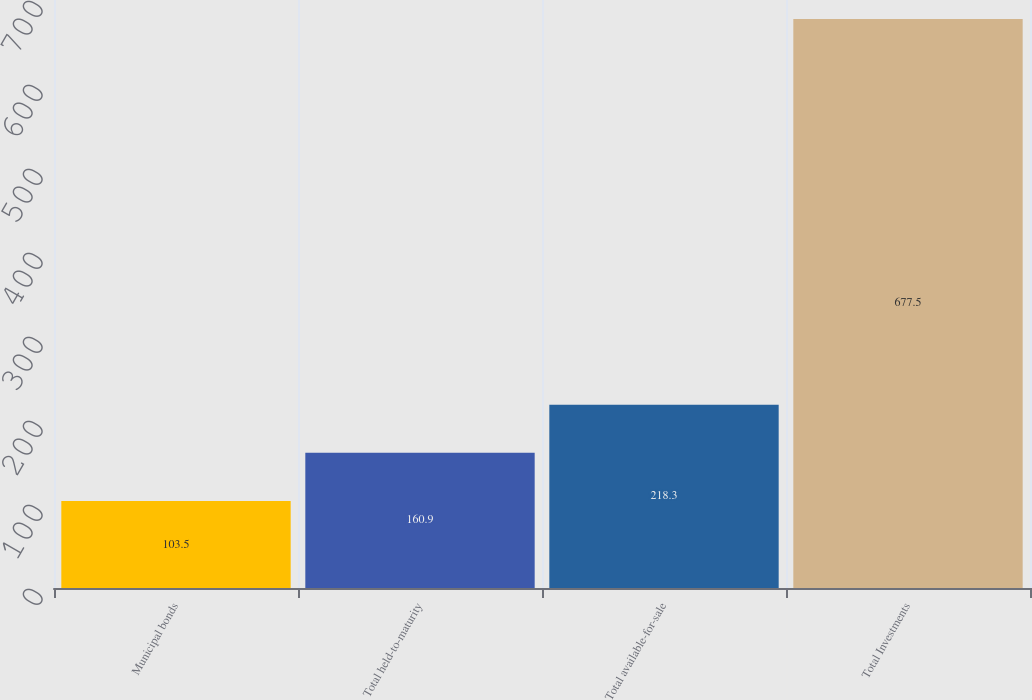Convert chart to OTSL. <chart><loc_0><loc_0><loc_500><loc_500><bar_chart><fcel>Municipal bonds<fcel>Total held-to-maturity<fcel>Total available-for-sale<fcel>Total Investments<nl><fcel>103.5<fcel>160.9<fcel>218.3<fcel>677.5<nl></chart> 